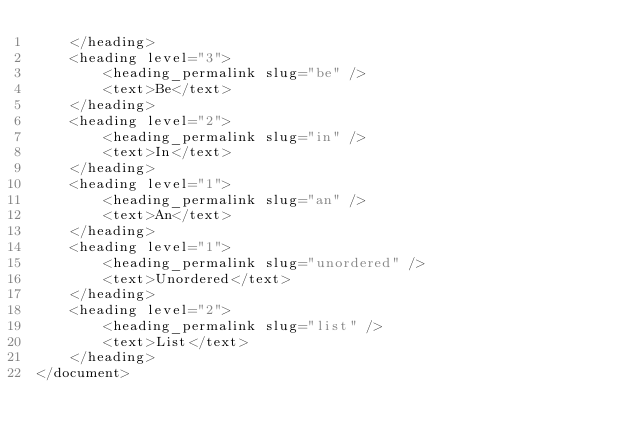Convert code to text. <code><loc_0><loc_0><loc_500><loc_500><_XML_>    </heading>
    <heading level="3">
        <heading_permalink slug="be" />
        <text>Be</text>
    </heading>
    <heading level="2">
        <heading_permalink slug="in" />
        <text>In</text>
    </heading>
    <heading level="1">
        <heading_permalink slug="an" />
        <text>An</text>
    </heading>
    <heading level="1">
        <heading_permalink slug="unordered" />
        <text>Unordered</text>
    </heading>
    <heading level="2">
        <heading_permalink slug="list" />
        <text>List</text>
    </heading>
</document>
</code> 